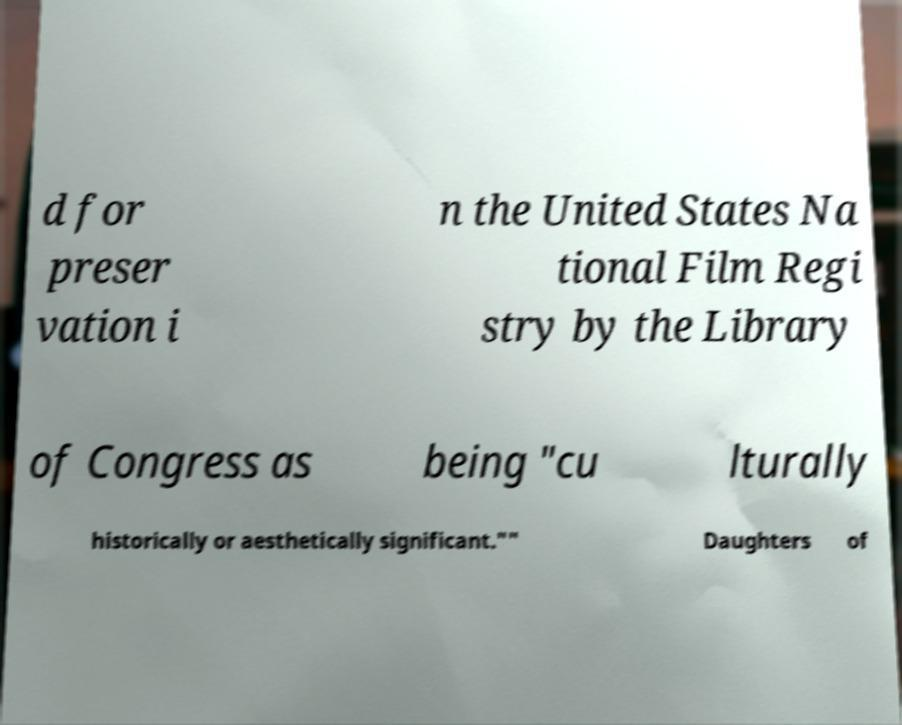For documentation purposes, I need the text within this image transcribed. Could you provide that? d for preser vation i n the United States Na tional Film Regi stry by the Library of Congress as being "cu lturally historically or aesthetically significant."" Daughters of 